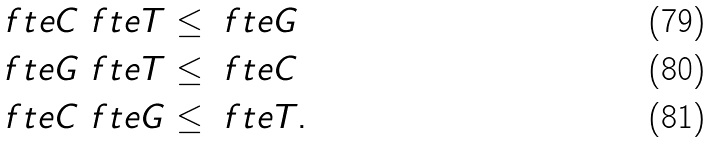<formula> <loc_0><loc_0><loc_500><loc_500>\ f t { e } { C } \ f t { e } { T } & \leq \ f t { e } { G } \\ \ f t { e } { G } \ f t { e } { T } & \leq \ f t { e } { C } \\ \ f t { e } { C } \ f t { e } { G } & \leq \ f t { e } { T } .</formula> 